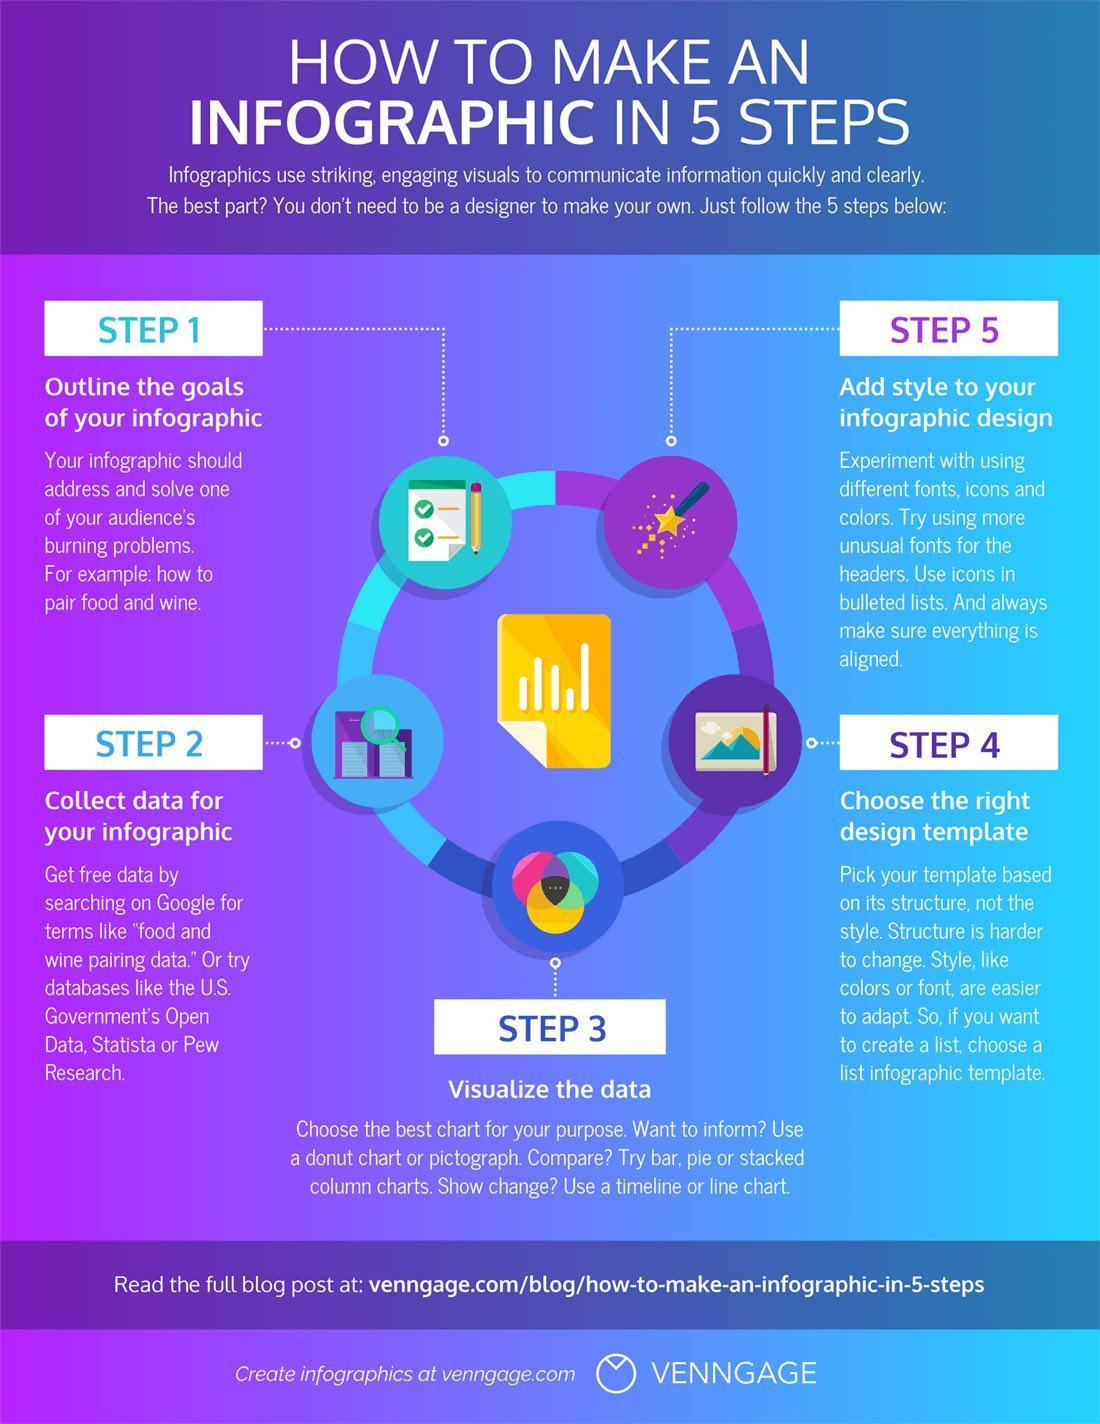Which is the 5th step to make an infographic?
Answer the question with a short phrase. Add style to your infographic design Which is the third step to make an infographic? Collect data for your infographic 